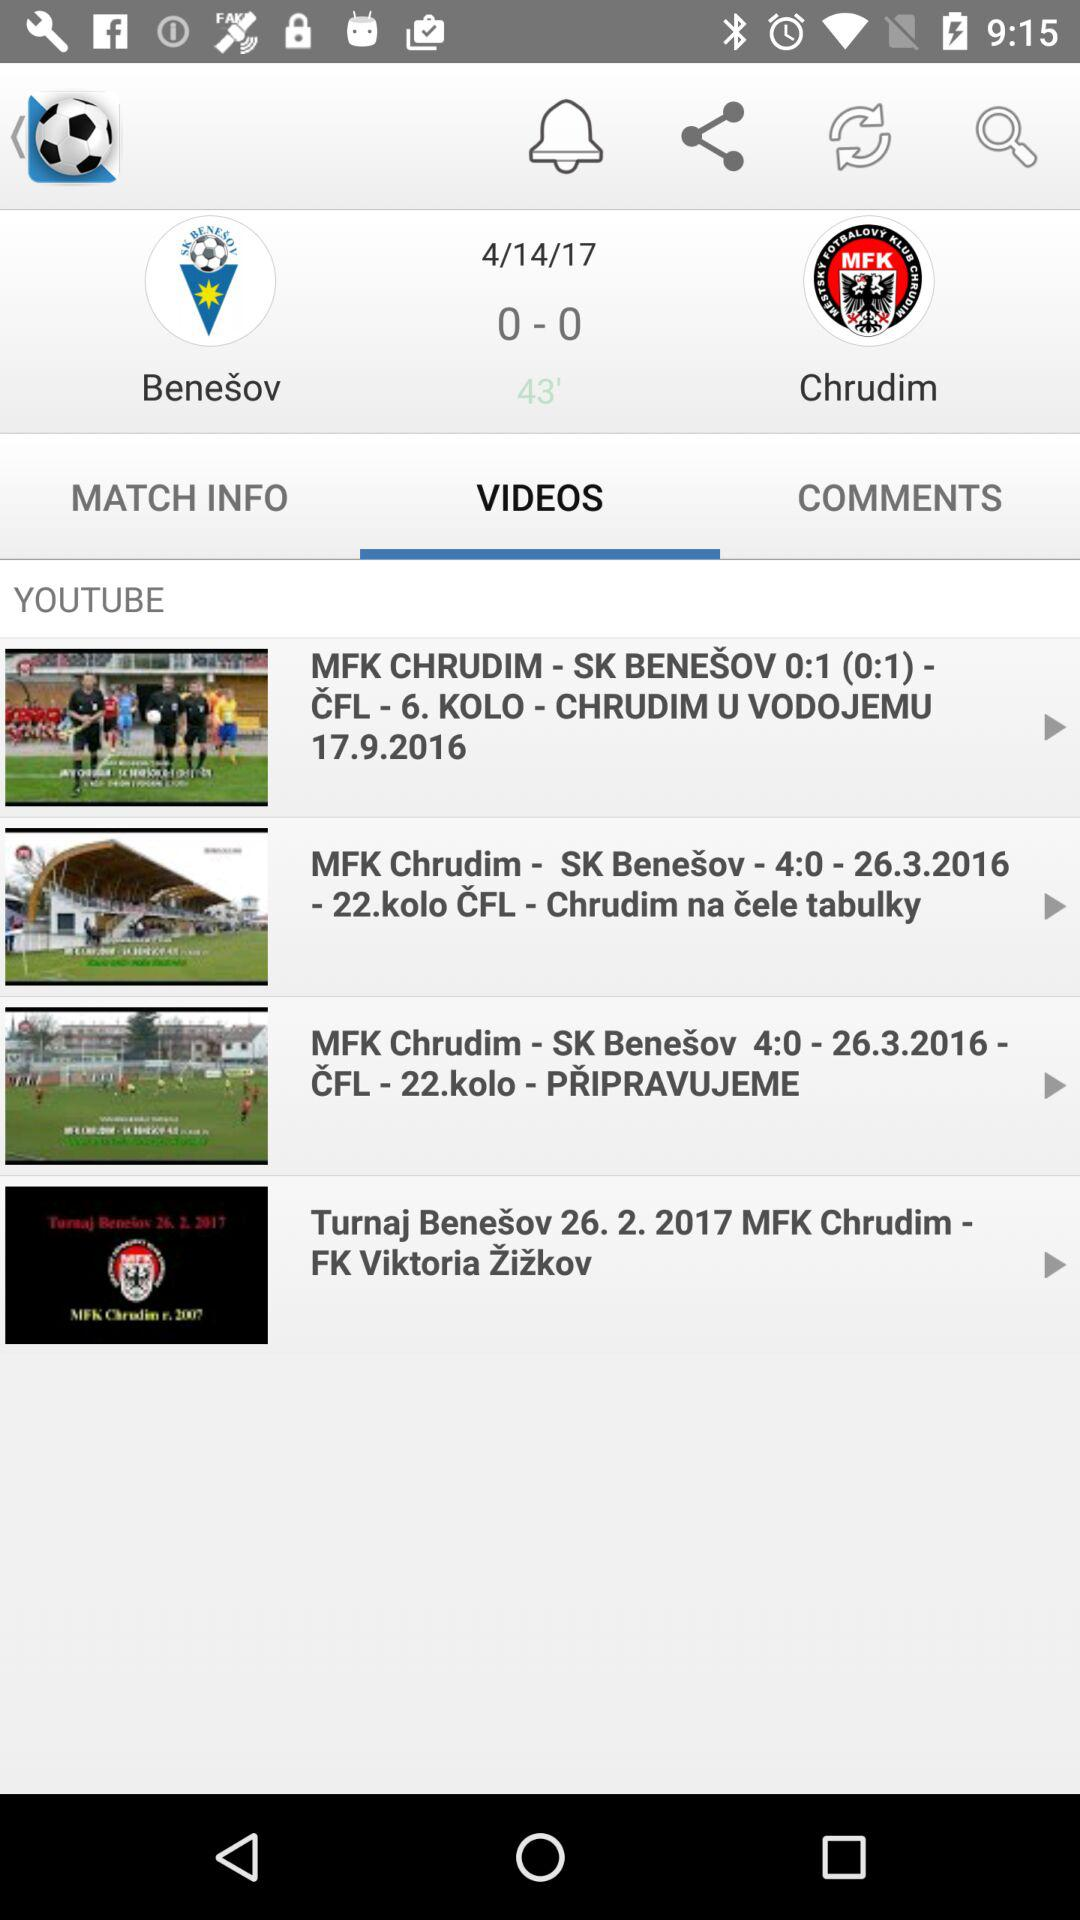What date is displayed on the screen? The dates displayed are April 14, 2017; September 17, 2016; March 26, 2016 and February 26, 2017. 